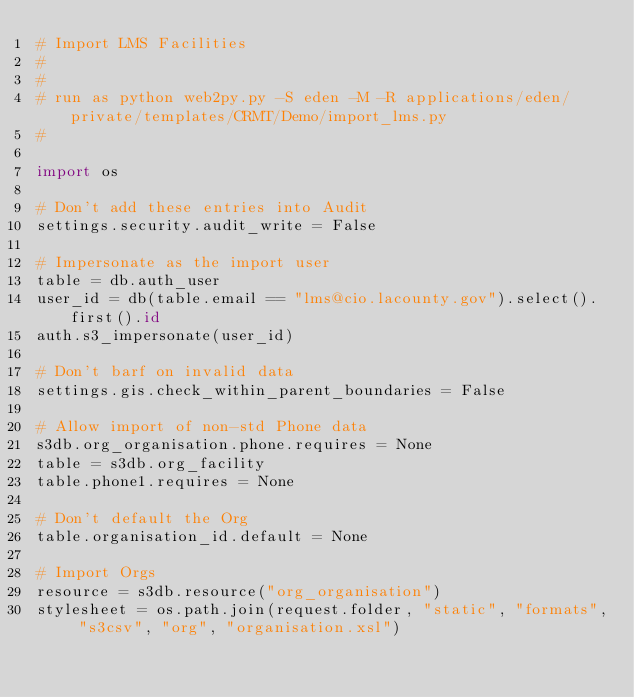Convert code to text. <code><loc_0><loc_0><loc_500><loc_500><_Python_># Import LMS Facilities
#
#
# run as python web2py.py -S eden -M -R applications/eden/private/templates/CRMT/Demo/import_lms.py
#

import os

# Don't add these entries into Audit
settings.security.audit_write = False

# Impersonate as the import user
table = db.auth_user
user_id = db(table.email == "lms@cio.lacounty.gov").select().first().id
auth.s3_impersonate(user_id)

# Don't barf on invalid data
settings.gis.check_within_parent_boundaries = False

# Allow import of non-std Phone data
s3db.org_organisation.phone.requires = None
table = s3db.org_facility
table.phone1.requires = None

# Don't default the Org
table.organisation_id.default = None

# Import Orgs
resource = s3db.resource("org_organisation")
stylesheet = os.path.join(request.folder, "static", "formats", "s3csv", "org", "organisation.xsl")</code> 